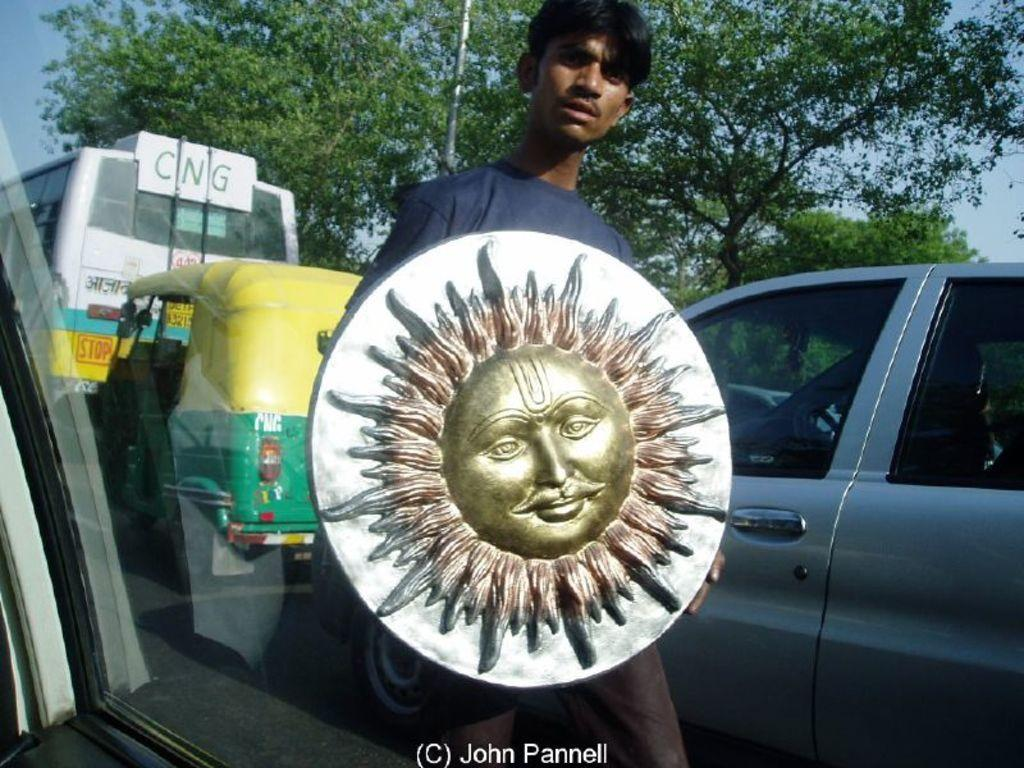What is the person in the image doing? The person is standing in the image. What is the person holding in the image? The person is holding an object. What can be seen on the object the person is holding? The object has an artifact on it. What can be seen in the background of the image? There are vehicles and trees in the background of the image. What type of writing can be seen on the artifact in the image? There is no writing visible on the artifact in the image. Can you see any bees flying around the person in the image? There are no bees present in the image. 